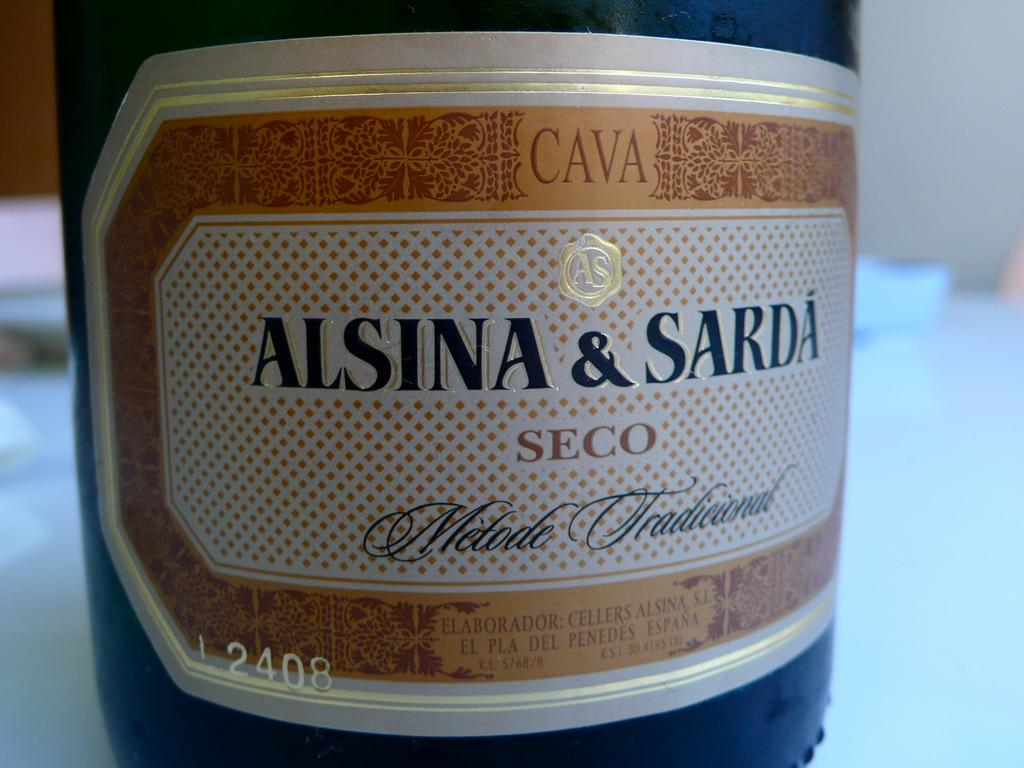<image>
Offer a succinct explanation of the picture presented. A bottle of alsina and sarda seco with cava on top of the label 